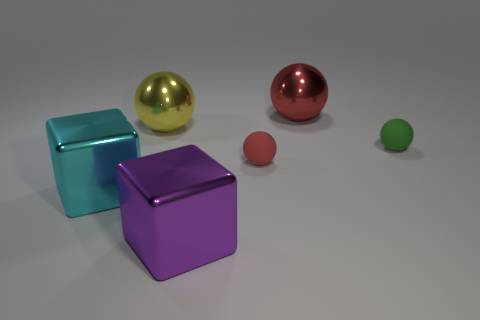Subtract all red shiny balls. How many balls are left? 3 Add 1 yellow metallic things. How many objects exist? 7 Subtract all red spheres. How many spheres are left? 2 Subtract all green cylinders. How many red balls are left? 2 Add 3 metallic things. How many metallic things are left? 7 Add 2 large metal things. How many large metal things exist? 6 Subtract 0 yellow blocks. How many objects are left? 6 Subtract all blocks. How many objects are left? 4 Subtract all purple blocks. Subtract all yellow spheres. How many blocks are left? 1 Subtract all large rubber balls. Subtract all cyan metallic objects. How many objects are left? 5 